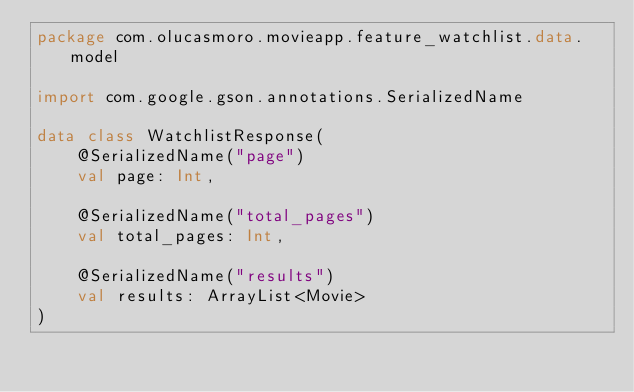Convert code to text. <code><loc_0><loc_0><loc_500><loc_500><_Kotlin_>package com.olucasmoro.movieapp.feature_watchlist.data.model

import com.google.gson.annotations.SerializedName

data class WatchlistResponse(
    @SerializedName("page")
    val page: Int,

    @SerializedName("total_pages")
    val total_pages: Int,

    @SerializedName("results")
    val results: ArrayList<Movie>
)</code> 